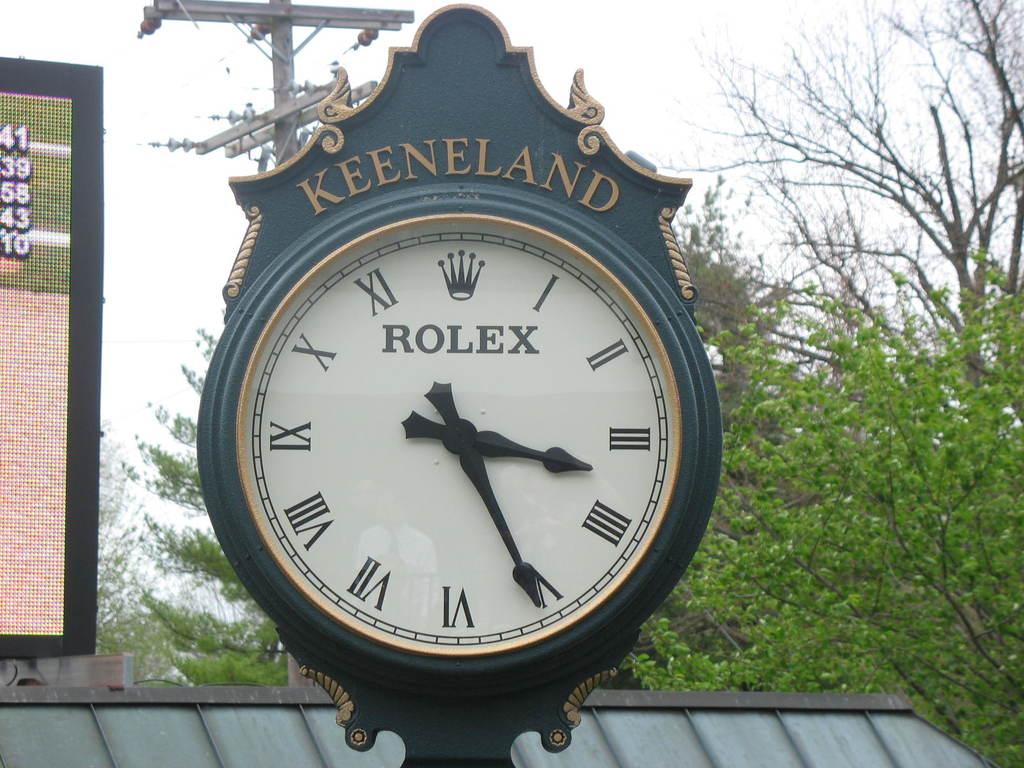Who made the clockface?
Provide a succinct answer. Rolex. What is the name above the clock itself?
Offer a very short reply. Keeneland. 